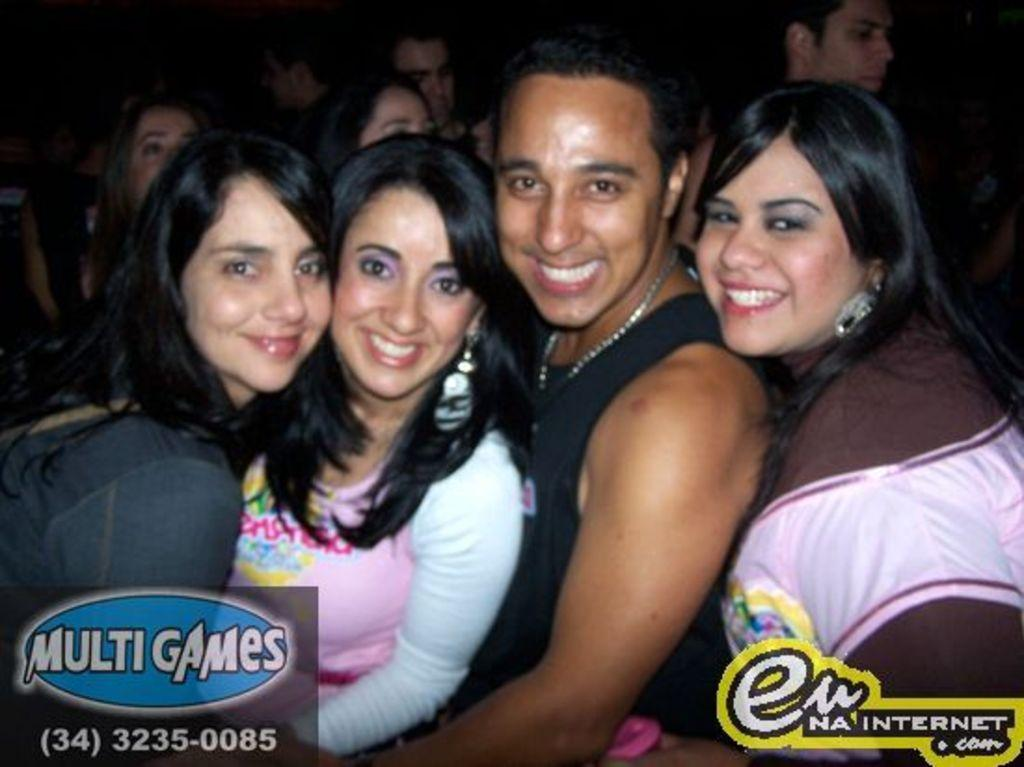Who or what is present in the image? A: There are people in the image. What are the people doing in the image? The people are smiling in the image. Are there any identifiable symbols or marks at the bottom of the image? Yes, there are logos at the bottom of the image. How many teeth can be seen in the image? There are no teeth visible in the image. What type of bears are present in the image? There are no bears present in the image. 